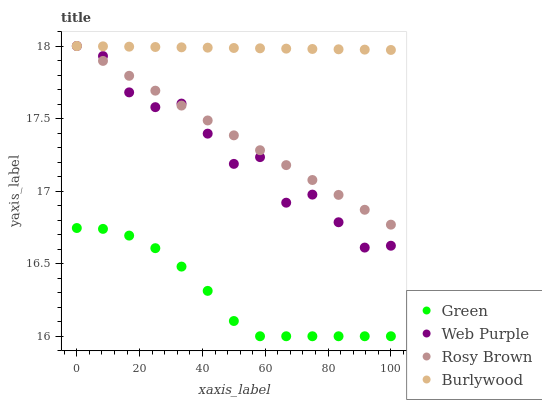Does Green have the minimum area under the curve?
Answer yes or no. Yes. Does Burlywood have the maximum area under the curve?
Answer yes or no. Yes. Does Web Purple have the minimum area under the curve?
Answer yes or no. No. Does Web Purple have the maximum area under the curve?
Answer yes or no. No. Is Rosy Brown the smoothest?
Answer yes or no. Yes. Is Web Purple the roughest?
Answer yes or no. Yes. Is Web Purple the smoothest?
Answer yes or no. No. Is Rosy Brown the roughest?
Answer yes or no. No. Does Green have the lowest value?
Answer yes or no. Yes. Does Web Purple have the lowest value?
Answer yes or no. No. Does Rosy Brown have the highest value?
Answer yes or no. Yes. Does Green have the highest value?
Answer yes or no. No. Is Green less than Rosy Brown?
Answer yes or no. Yes. Is Web Purple greater than Green?
Answer yes or no. Yes. Does Burlywood intersect Web Purple?
Answer yes or no. Yes. Is Burlywood less than Web Purple?
Answer yes or no. No. Is Burlywood greater than Web Purple?
Answer yes or no. No. Does Green intersect Rosy Brown?
Answer yes or no. No. 